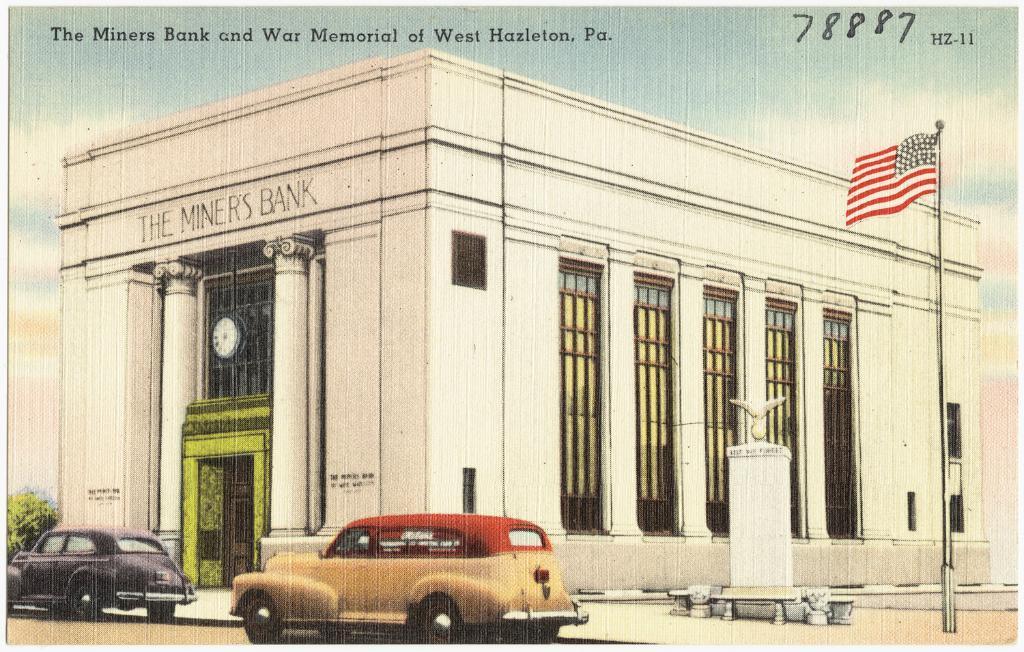Describe this image in one or two sentences. Here we can see an animated picture, in this picture we can see a building here, on the right side there is a flag, we can see two cars here, there is a plant here, we can see some text at the top of the picture. 